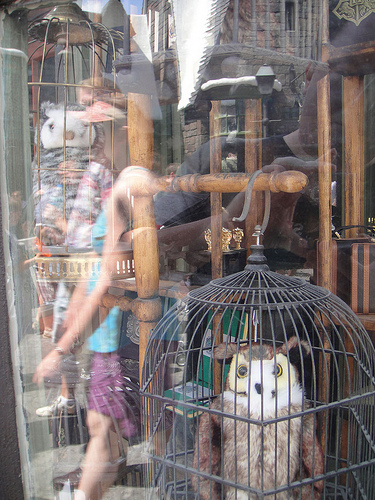<image>
Can you confirm if the stuffed owl is in the cage? Yes. The stuffed owl is contained within or inside the cage, showing a containment relationship. 